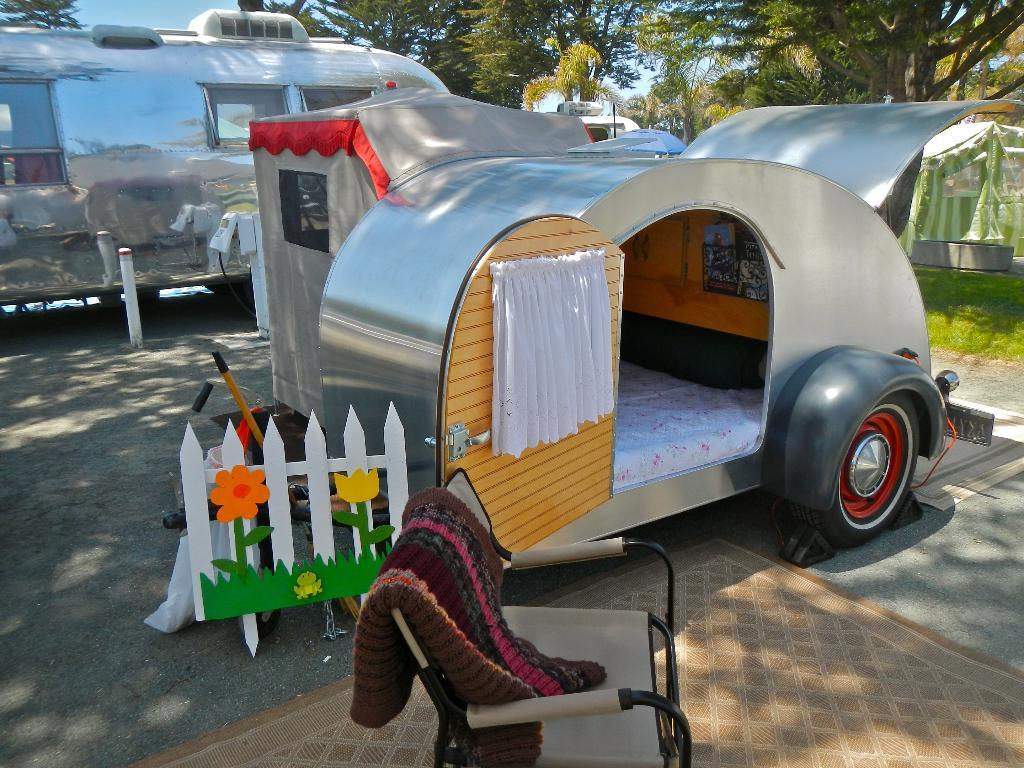What is located in the center of the image? There are vehicles in the center of the image. Where are the vehicles situated? The vehicles are on the ground. What is present at the bottom of the image? There is a chair and cloth at the bottom of the image. What can be seen in the background of the image? There are trees and the sky visible in the background of the image. What type of trail can be seen in the image? There is no trail present in the image; it features vehicles on the ground, a chair, cloth, trees, and the sky. 